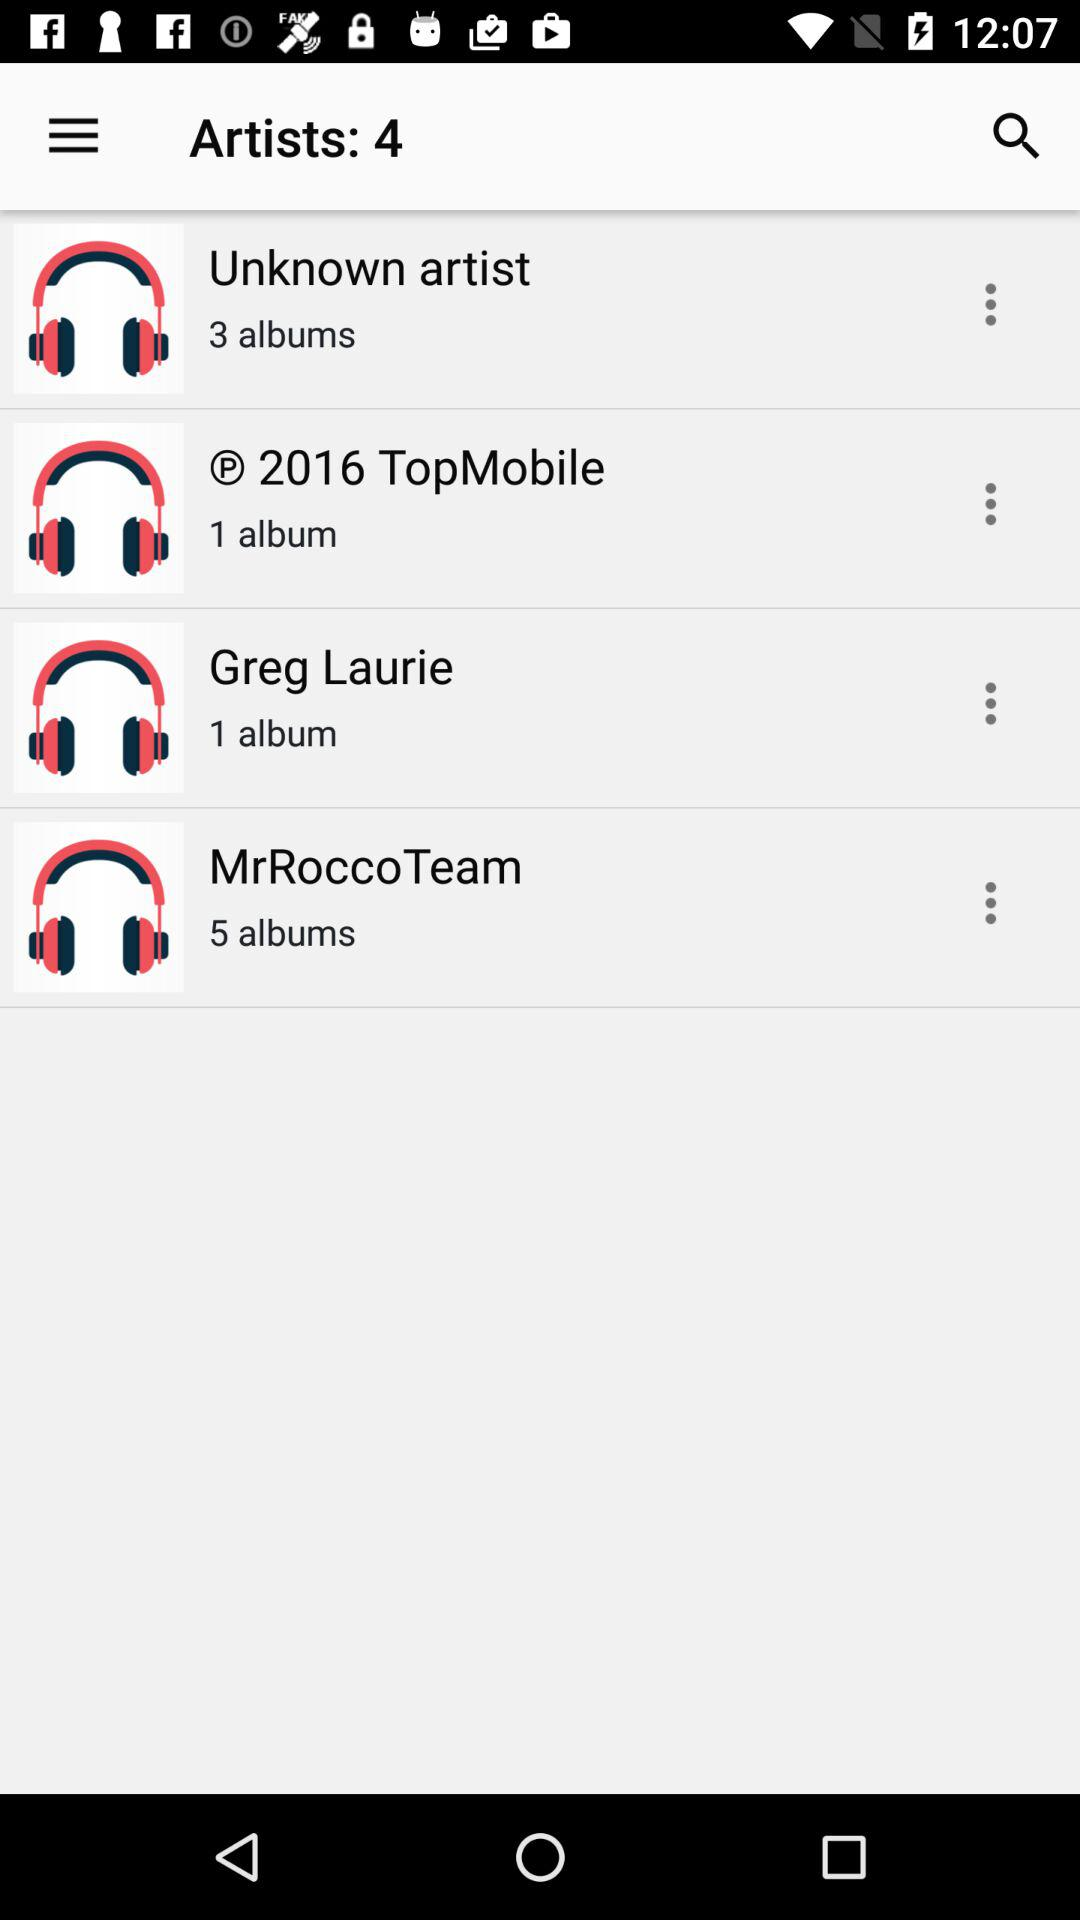How many albums are on the "© 2016 TopMobile"? "© 2016 TopMobile" contains 1 album. 